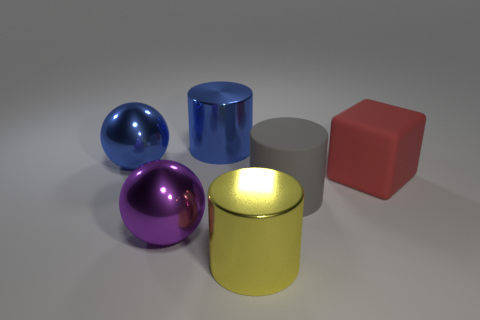How many objects are there, and can you describe their colors? There are five objects in the image. From left to right, you can see a blue sphere, a purple sphere, a blue cylinder, a grey cylinder, and a red cube. Each has a distinct, glossy material that catches the light differently. Which object seems to reflect the most light? The yellow cylindrical object at the center seems to reflect the most light, giving it a very bright and luminous appearance compared to the others. 